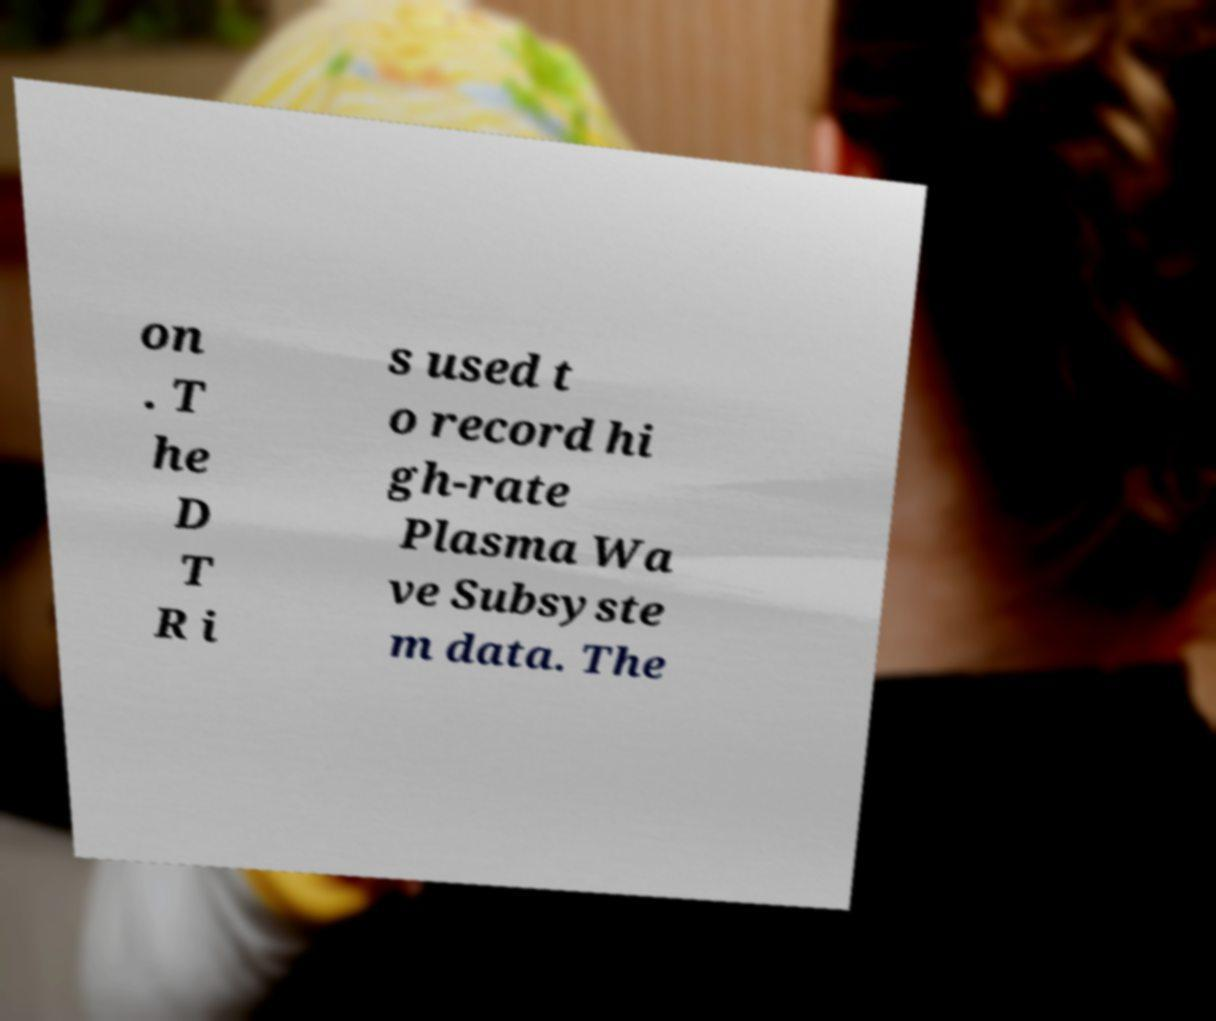What messages or text are displayed in this image? I need them in a readable, typed format. on . T he D T R i s used t o record hi gh-rate Plasma Wa ve Subsyste m data. The 